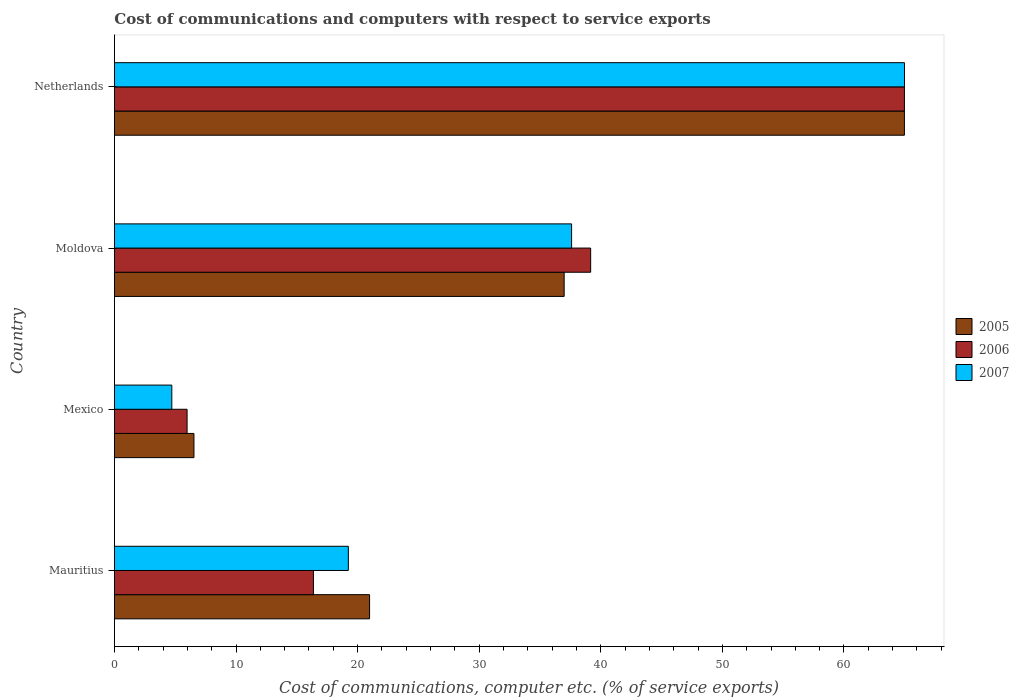How many different coloured bars are there?
Ensure brevity in your answer.  3. How many groups of bars are there?
Offer a very short reply. 4. Are the number of bars on each tick of the Y-axis equal?
Provide a succinct answer. Yes. How many bars are there on the 1st tick from the bottom?
Provide a short and direct response. 3. What is the label of the 3rd group of bars from the top?
Your answer should be very brief. Mexico. What is the cost of communications and computers in 2005 in Netherlands?
Your response must be concise. 64.97. Across all countries, what is the maximum cost of communications and computers in 2006?
Make the answer very short. 64.97. Across all countries, what is the minimum cost of communications and computers in 2005?
Your answer should be very brief. 6.54. In which country was the cost of communications and computers in 2006 maximum?
Your answer should be compact. Netherlands. What is the total cost of communications and computers in 2005 in the graph?
Provide a short and direct response. 129.48. What is the difference between the cost of communications and computers in 2006 in Moldova and that in Netherlands?
Provide a short and direct response. -25.81. What is the difference between the cost of communications and computers in 2006 in Netherlands and the cost of communications and computers in 2005 in Mauritius?
Offer a very short reply. 43.99. What is the average cost of communications and computers in 2006 per country?
Provide a short and direct response. 31.62. What is the difference between the cost of communications and computers in 2006 and cost of communications and computers in 2007 in Mexico?
Make the answer very short. 1.26. In how many countries, is the cost of communications and computers in 2006 greater than 52 %?
Ensure brevity in your answer.  1. What is the ratio of the cost of communications and computers in 2006 in Mauritius to that in Mexico?
Make the answer very short. 2.74. What is the difference between the highest and the second highest cost of communications and computers in 2007?
Keep it short and to the point. 27.38. What is the difference between the highest and the lowest cost of communications and computers in 2006?
Provide a succinct answer. 59. In how many countries, is the cost of communications and computers in 2007 greater than the average cost of communications and computers in 2007 taken over all countries?
Offer a very short reply. 2. Is it the case that in every country, the sum of the cost of communications and computers in 2005 and cost of communications and computers in 2007 is greater than the cost of communications and computers in 2006?
Keep it short and to the point. Yes. How many bars are there?
Your response must be concise. 12. How many countries are there in the graph?
Provide a short and direct response. 4. Does the graph contain any zero values?
Keep it short and to the point. No. Does the graph contain grids?
Your response must be concise. No. How many legend labels are there?
Ensure brevity in your answer.  3. What is the title of the graph?
Give a very brief answer. Cost of communications and computers with respect to service exports. What is the label or title of the X-axis?
Provide a succinct answer. Cost of communications, computer etc. (% of service exports). What is the Cost of communications, computer etc. (% of service exports) in 2005 in Mauritius?
Provide a short and direct response. 20.99. What is the Cost of communications, computer etc. (% of service exports) in 2006 in Mauritius?
Make the answer very short. 16.37. What is the Cost of communications, computer etc. (% of service exports) of 2007 in Mauritius?
Your answer should be compact. 19.24. What is the Cost of communications, computer etc. (% of service exports) of 2005 in Mexico?
Provide a short and direct response. 6.54. What is the Cost of communications, computer etc. (% of service exports) in 2006 in Mexico?
Your answer should be compact. 5.98. What is the Cost of communications, computer etc. (% of service exports) of 2007 in Mexico?
Offer a terse response. 4.72. What is the Cost of communications, computer etc. (% of service exports) of 2005 in Moldova?
Your answer should be very brief. 36.99. What is the Cost of communications, computer etc. (% of service exports) in 2006 in Moldova?
Your answer should be very brief. 39.17. What is the Cost of communications, computer etc. (% of service exports) of 2007 in Moldova?
Offer a terse response. 37.6. What is the Cost of communications, computer etc. (% of service exports) of 2005 in Netherlands?
Offer a very short reply. 64.97. What is the Cost of communications, computer etc. (% of service exports) in 2006 in Netherlands?
Your answer should be compact. 64.97. What is the Cost of communications, computer etc. (% of service exports) of 2007 in Netherlands?
Your answer should be very brief. 64.98. Across all countries, what is the maximum Cost of communications, computer etc. (% of service exports) of 2005?
Your answer should be compact. 64.97. Across all countries, what is the maximum Cost of communications, computer etc. (% of service exports) in 2006?
Ensure brevity in your answer.  64.97. Across all countries, what is the maximum Cost of communications, computer etc. (% of service exports) of 2007?
Provide a succinct answer. 64.98. Across all countries, what is the minimum Cost of communications, computer etc. (% of service exports) in 2005?
Make the answer very short. 6.54. Across all countries, what is the minimum Cost of communications, computer etc. (% of service exports) in 2006?
Offer a terse response. 5.98. Across all countries, what is the minimum Cost of communications, computer etc. (% of service exports) in 2007?
Your response must be concise. 4.72. What is the total Cost of communications, computer etc. (% of service exports) of 2005 in the graph?
Make the answer very short. 129.48. What is the total Cost of communications, computer etc. (% of service exports) of 2006 in the graph?
Offer a terse response. 126.48. What is the total Cost of communications, computer etc. (% of service exports) in 2007 in the graph?
Your answer should be very brief. 126.54. What is the difference between the Cost of communications, computer etc. (% of service exports) in 2005 in Mauritius and that in Mexico?
Offer a terse response. 14.45. What is the difference between the Cost of communications, computer etc. (% of service exports) in 2006 in Mauritius and that in Mexico?
Give a very brief answer. 10.39. What is the difference between the Cost of communications, computer etc. (% of service exports) in 2007 in Mauritius and that in Mexico?
Provide a short and direct response. 14.52. What is the difference between the Cost of communications, computer etc. (% of service exports) of 2005 in Mauritius and that in Moldova?
Provide a short and direct response. -16. What is the difference between the Cost of communications, computer etc. (% of service exports) of 2006 in Mauritius and that in Moldova?
Your response must be concise. -22.8. What is the difference between the Cost of communications, computer etc. (% of service exports) of 2007 in Mauritius and that in Moldova?
Offer a very short reply. -18.36. What is the difference between the Cost of communications, computer etc. (% of service exports) in 2005 in Mauritius and that in Netherlands?
Offer a terse response. -43.99. What is the difference between the Cost of communications, computer etc. (% of service exports) of 2006 in Mauritius and that in Netherlands?
Offer a very short reply. -48.61. What is the difference between the Cost of communications, computer etc. (% of service exports) of 2007 in Mauritius and that in Netherlands?
Make the answer very short. -45.74. What is the difference between the Cost of communications, computer etc. (% of service exports) in 2005 in Mexico and that in Moldova?
Offer a very short reply. -30.45. What is the difference between the Cost of communications, computer etc. (% of service exports) in 2006 in Mexico and that in Moldova?
Make the answer very short. -33.19. What is the difference between the Cost of communications, computer etc. (% of service exports) of 2007 in Mexico and that in Moldova?
Your answer should be very brief. -32.88. What is the difference between the Cost of communications, computer etc. (% of service exports) of 2005 in Mexico and that in Netherlands?
Ensure brevity in your answer.  -58.43. What is the difference between the Cost of communications, computer etc. (% of service exports) in 2006 in Mexico and that in Netherlands?
Make the answer very short. -59. What is the difference between the Cost of communications, computer etc. (% of service exports) in 2007 in Mexico and that in Netherlands?
Make the answer very short. -60.26. What is the difference between the Cost of communications, computer etc. (% of service exports) in 2005 in Moldova and that in Netherlands?
Your answer should be very brief. -27.98. What is the difference between the Cost of communications, computer etc. (% of service exports) in 2006 in Moldova and that in Netherlands?
Make the answer very short. -25.81. What is the difference between the Cost of communications, computer etc. (% of service exports) in 2007 in Moldova and that in Netherlands?
Your response must be concise. -27.38. What is the difference between the Cost of communications, computer etc. (% of service exports) in 2005 in Mauritius and the Cost of communications, computer etc. (% of service exports) in 2006 in Mexico?
Offer a very short reply. 15.01. What is the difference between the Cost of communications, computer etc. (% of service exports) of 2005 in Mauritius and the Cost of communications, computer etc. (% of service exports) of 2007 in Mexico?
Make the answer very short. 16.27. What is the difference between the Cost of communications, computer etc. (% of service exports) in 2006 in Mauritius and the Cost of communications, computer etc. (% of service exports) in 2007 in Mexico?
Give a very brief answer. 11.65. What is the difference between the Cost of communications, computer etc. (% of service exports) of 2005 in Mauritius and the Cost of communications, computer etc. (% of service exports) of 2006 in Moldova?
Give a very brief answer. -18.18. What is the difference between the Cost of communications, computer etc. (% of service exports) of 2005 in Mauritius and the Cost of communications, computer etc. (% of service exports) of 2007 in Moldova?
Keep it short and to the point. -16.61. What is the difference between the Cost of communications, computer etc. (% of service exports) of 2006 in Mauritius and the Cost of communications, computer etc. (% of service exports) of 2007 in Moldova?
Your answer should be very brief. -21.23. What is the difference between the Cost of communications, computer etc. (% of service exports) in 2005 in Mauritius and the Cost of communications, computer etc. (% of service exports) in 2006 in Netherlands?
Provide a short and direct response. -43.99. What is the difference between the Cost of communications, computer etc. (% of service exports) in 2005 in Mauritius and the Cost of communications, computer etc. (% of service exports) in 2007 in Netherlands?
Offer a very short reply. -43.99. What is the difference between the Cost of communications, computer etc. (% of service exports) in 2006 in Mauritius and the Cost of communications, computer etc. (% of service exports) in 2007 in Netherlands?
Provide a short and direct response. -48.61. What is the difference between the Cost of communications, computer etc. (% of service exports) of 2005 in Mexico and the Cost of communications, computer etc. (% of service exports) of 2006 in Moldova?
Your response must be concise. -32.63. What is the difference between the Cost of communications, computer etc. (% of service exports) of 2005 in Mexico and the Cost of communications, computer etc. (% of service exports) of 2007 in Moldova?
Ensure brevity in your answer.  -31.06. What is the difference between the Cost of communications, computer etc. (% of service exports) of 2006 in Mexico and the Cost of communications, computer etc. (% of service exports) of 2007 in Moldova?
Keep it short and to the point. -31.62. What is the difference between the Cost of communications, computer etc. (% of service exports) of 2005 in Mexico and the Cost of communications, computer etc. (% of service exports) of 2006 in Netherlands?
Provide a short and direct response. -58.43. What is the difference between the Cost of communications, computer etc. (% of service exports) in 2005 in Mexico and the Cost of communications, computer etc. (% of service exports) in 2007 in Netherlands?
Provide a succinct answer. -58.44. What is the difference between the Cost of communications, computer etc. (% of service exports) of 2006 in Mexico and the Cost of communications, computer etc. (% of service exports) of 2007 in Netherlands?
Ensure brevity in your answer.  -59. What is the difference between the Cost of communications, computer etc. (% of service exports) in 2005 in Moldova and the Cost of communications, computer etc. (% of service exports) in 2006 in Netherlands?
Your answer should be very brief. -27.99. What is the difference between the Cost of communications, computer etc. (% of service exports) in 2005 in Moldova and the Cost of communications, computer etc. (% of service exports) in 2007 in Netherlands?
Your response must be concise. -27.99. What is the difference between the Cost of communications, computer etc. (% of service exports) of 2006 in Moldova and the Cost of communications, computer etc. (% of service exports) of 2007 in Netherlands?
Your answer should be very brief. -25.81. What is the average Cost of communications, computer etc. (% of service exports) in 2005 per country?
Offer a very short reply. 32.37. What is the average Cost of communications, computer etc. (% of service exports) in 2006 per country?
Your answer should be compact. 31.62. What is the average Cost of communications, computer etc. (% of service exports) of 2007 per country?
Your answer should be very brief. 31.63. What is the difference between the Cost of communications, computer etc. (% of service exports) in 2005 and Cost of communications, computer etc. (% of service exports) in 2006 in Mauritius?
Give a very brief answer. 4.62. What is the difference between the Cost of communications, computer etc. (% of service exports) in 2005 and Cost of communications, computer etc. (% of service exports) in 2007 in Mauritius?
Provide a succinct answer. 1.75. What is the difference between the Cost of communications, computer etc. (% of service exports) in 2006 and Cost of communications, computer etc. (% of service exports) in 2007 in Mauritius?
Provide a succinct answer. -2.87. What is the difference between the Cost of communications, computer etc. (% of service exports) in 2005 and Cost of communications, computer etc. (% of service exports) in 2006 in Mexico?
Keep it short and to the point. 0.56. What is the difference between the Cost of communications, computer etc. (% of service exports) of 2005 and Cost of communications, computer etc. (% of service exports) of 2007 in Mexico?
Offer a very short reply. 1.82. What is the difference between the Cost of communications, computer etc. (% of service exports) of 2006 and Cost of communications, computer etc. (% of service exports) of 2007 in Mexico?
Your answer should be compact. 1.26. What is the difference between the Cost of communications, computer etc. (% of service exports) in 2005 and Cost of communications, computer etc. (% of service exports) in 2006 in Moldova?
Offer a terse response. -2.18. What is the difference between the Cost of communications, computer etc. (% of service exports) in 2005 and Cost of communications, computer etc. (% of service exports) in 2007 in Moldova?
Your answer should be compact. -0.61. What is the difference between the Cost of communications, computer etc. (% of service exports) in 2006 and Cost of communications, computer etc. (% of service exports) in 2007 in Moldova?
Provide a short and direct response. 1.57. What is the difference between the Cost of communications, computer etc. (% of service exports) in 2005 and Cost of communications, computer etc. (% of service exports) in 2006 in Netherlands?
Make the answer very short. -0. What is the difference between the Cost of communications, computer etc. (% of service exports) in 2005 and Cost of communications, computer etc. (% of service exports) in 2007 in Netherlands?
Ensure brevity in your answer.  -0.01. What is the difference between the Cost of communications, computer etc. (% of service exports) in 2006 and Cost of communications, computer etc. (% of service exports) in 2007 in Netherlands?
Ensure brevity in your answer.  -0.01. What is the ratio of the Cost of communications, computer etc. (% of service exports) of 2005 in Mauritius to that in Mexico?
Keep it short and to the point. 3.21. What is the ratio of the Cost of communications, computer etc. (% of service exports) in 2006 in Mauritius to that in Mexico?
Give a very brief answer. 2.74. What is the ratio of the Cost of communications, computer etc. (% of service exports) in 2007 in Mauritius to that in Mexico?
Provide a succinct answer. 4.08. What is the ratio of the Cost of communications, computer etc. (% of service exports) of 2005 in Mauritius to that in Moldova?
Provide a succinct answer. 0.57. What is the ratio of the Cost of communications, computer etc. (% of service exports) of 2006 in Mauritius to that in Moldova?
Ensure brevity in your answer.  0.42. What is the ratio of the Cost of communications, computer etc. (% of service exports) in 2007 in Mauritius to that in Moldova?
Give a very brief answer. 0.51. What is the ratio of the Cost of communications, computer etc. (% of service exports) in 2005 in Mauritius to that in Netherlands?
Keep it short and to the point. 0.32. What is the ratio of the Cost of communications, computer etc. (% of service exports) in 2006 in Mauritius to that in Netherlands?
Ensure brevity in your answer.  0.25. What is the ratio of the Cost of communications, computer etc. (% of service exports) of 2007 in Mauritius to that in Netherlands?
Make the answer very short. 0.3. What is the ratio of the Cost of communications, computer etc. (% of service exports) of 2005 in Mexico to that in Moldova?
Offer a very short reply. 0.18. What is the ratio of the Cost of communications, computer etc. (% of service exports) in 2006 in Mexico to that in Moldova?
Your answer should be very brief. 0.15. What is the ratio of the Cost of communications, computer etc. (% of service exports) in 2007 in Mexico to that in Moldova?
Offer a very short reply. 0.13. What is the ratio of the Cost of communications, computer etc. (% of service exports) in 2005 in Mexico to that in Netherlands?
Ensure brevity in your answer.  0.1. What is the ratio of the Cost of communications, computer etc. (% of service exports) in 2006 in Mexico to that in Netherlands?
Your answer should be compact. 0.09. What is the ratio of the Cost of communications, computer etc. (% of service exports) in 2007 in Mexico to that in Netherlands?
Provide a succinct answer. 0.07. What is the ratio of the Cost of communications, computer etc. (% of service exports) in 2005 in Moldova to that in Netherlands?
Your answer should be very brief. 0.57. What is the ratio of the Cost of communications, computer etc. (% of service exports) in 2006 in Moldova to that in Netherlands?
Give a very brief answer. 0.6. What is the ratio of the Cost of communications, computer etc. (% of service exports) in 2007 in Moldova to that in Netherlands?
Ensure brevity in your answer.  0.58. What is the difference between the highest and the second highest Cost of communications, computer etc. (% of service exports) in 2005?
Offer a very short reply. 27.98. What is the difference between the highest and the second highest Cost of communications, computer etc. (% of service exports) in 2006?
Your answer should be compact. 25.81. What is the difference between the highest and the second highest Cost of communications, computer etc. (% of service exports) in 2007?
Your answer should be compact. 27.38. What is the difference between the highest and the lowest Cost of communications, computer etc. (% of service exports) of 2005?
Your response must be concise. 58.43. What is the difference between the highest and the lowest Cost of communications, computer etc. (% of service exports) in 2006?
Your answer should be compact. 59. What is the difference between the highest and the lowest Cost of communications, computer etc. (% of service exports) of 2007?
Provide a short and direct response. 60.26. 